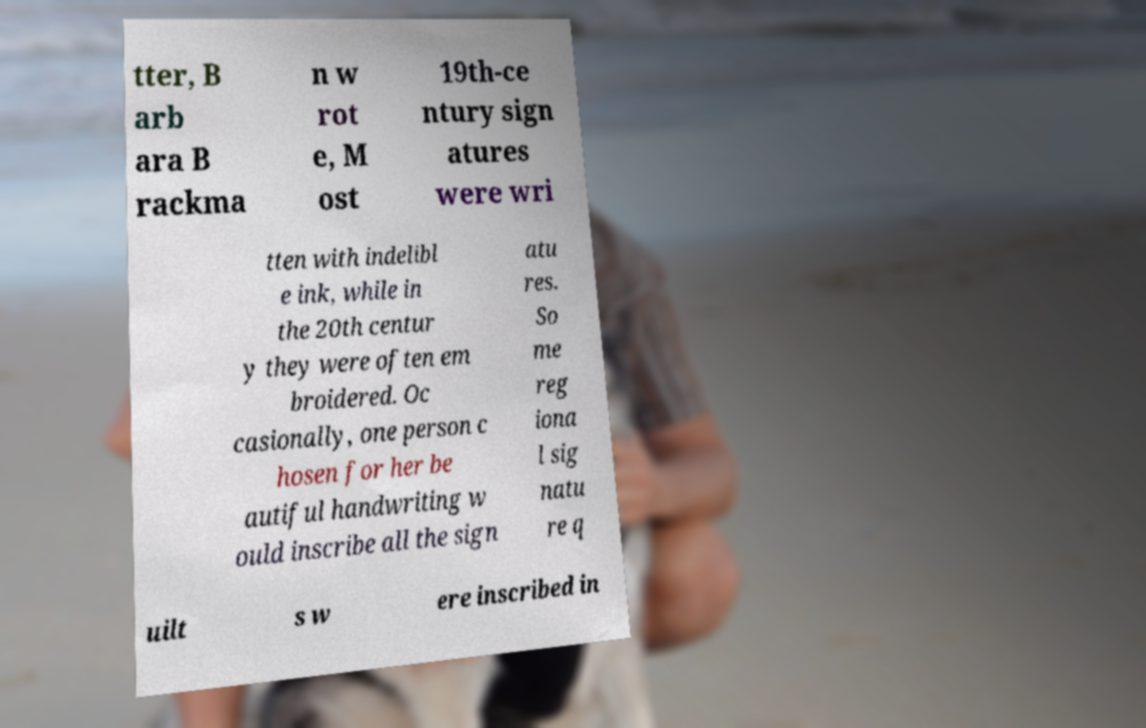Could you extract and type out the text from this image? tter, B arb ara B rackma n w rot e, M ost 19th-ce ntury sign atures were wri tten with indelibl e ink, while in the 20th centur y they were often em broidered. Oc casionally, one person c hosen for her be autiful handwriting w ould inscribe all the sign atu res. So me reg iona l sig natu re q uilt s w ere inscribed in 